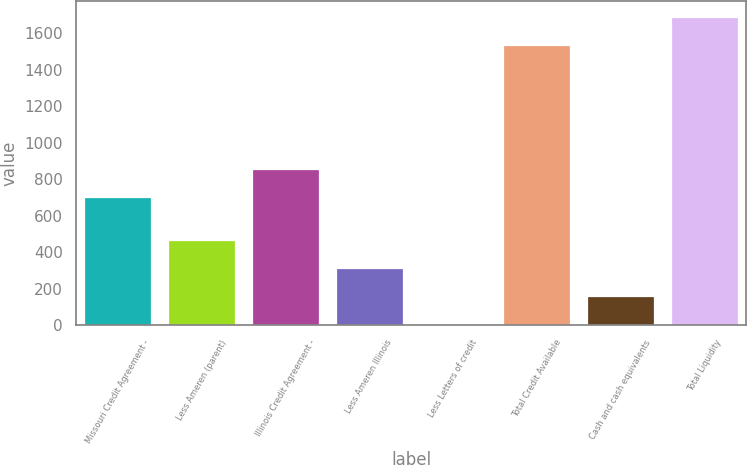<chart> <loc_0><loc_0><loc_500><loc_500><bar_chart><fcel>Missouri Credit Agreement -<fcel>Less Ameren (parent)<fcel>Illinois Credit Agreement -<fcel>Less Ameren Illinois<fcel>Less Letters of credit<fcel>Total Credit Available<fcel>Cash and cash equivalents<fcel>Total Liquidity<nl><fcel>704<fcel>466.9<fcel>858.3<fcel>312.6<fcel>4<fcel>1538<fcel>158.3<fcel>1692.3<nl></chart> 